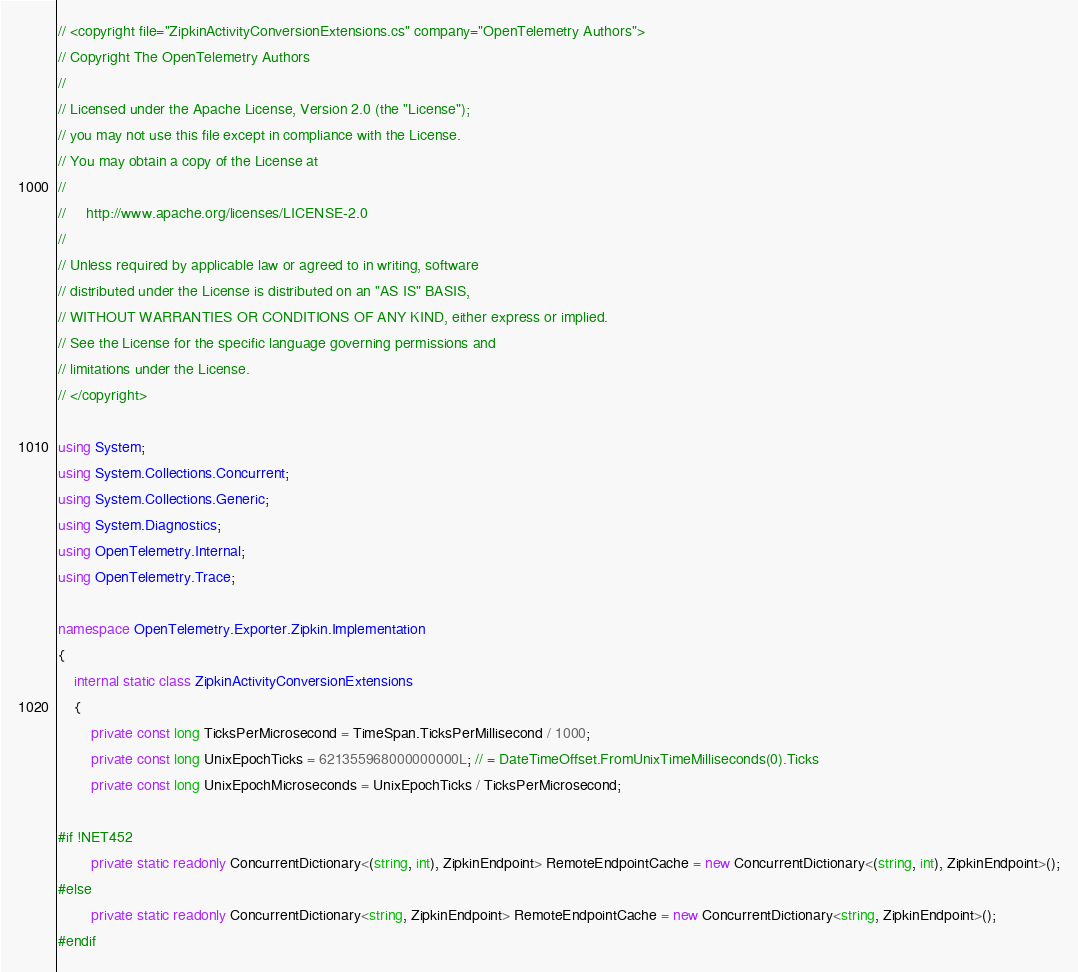Convert code to text. <code><loc_0><loc_0><loc_500><loc_500><_C#_>// <copyright file="ZipkinActivityConversionExtensions.cs" company="OpenTelemetry Authors">
// Copyright The OpenTelemetry Authors
//
// Licensed under the Apache License, Version 2.0 (the "License");
// you may not use this file except in compliance with the License.
// You may obtain a copy of the License at
//
//     http://www.apache.org/licenses/LICENSE-2.0
//
// Unless required by applicable law or agreed to in writing, software
// distributed under the License is distributed on an "AS IS" BASIS,
// WITHOUT WARRANTIES OR CONDITIONS OF ANY KIND, either express or implied.
// See the License for the specific language governing permissions and
// limitations under the License.
// </copyright>

using System;
using System.Collections.Concurrent;
using System.Collections.Generic;
using System.Diagnostics;
using OpenTelemetry.Internal;
using OpenTelemetry.Trace;

namespace OpenTelemetry.Exporter.Zipkin.Implementation
{
    internal static class ZipkinActivityConversionExtensions
    {
        private const long TicksPerMicrosecond = TimeSpan.TicksPerMillisecond / 1000;
        private const long UnixEpochTicks = 621355968000000000L; // = DateTimeOffset.FromUnixTimeMilliseconds(0).Ticks
        private const long UnixEpochMicroseconds = UnixEpochTicks / TicksPerMicrosecond;

#if !NET452
        private static readonly ConcurrentDictionary<(string, int), ZipkinEndpoint> RemoteEndpointCache = new ConcurrentDictionary<(string, int), ZipkinEndpoint>();
#else
        private static readonly ConcurrentDictionary<string, ZipkinEndpoint> RemoteEndpointCache = new ConcurrentDictionary<string, ZipkinEndpoint>();
#endif
</code> 